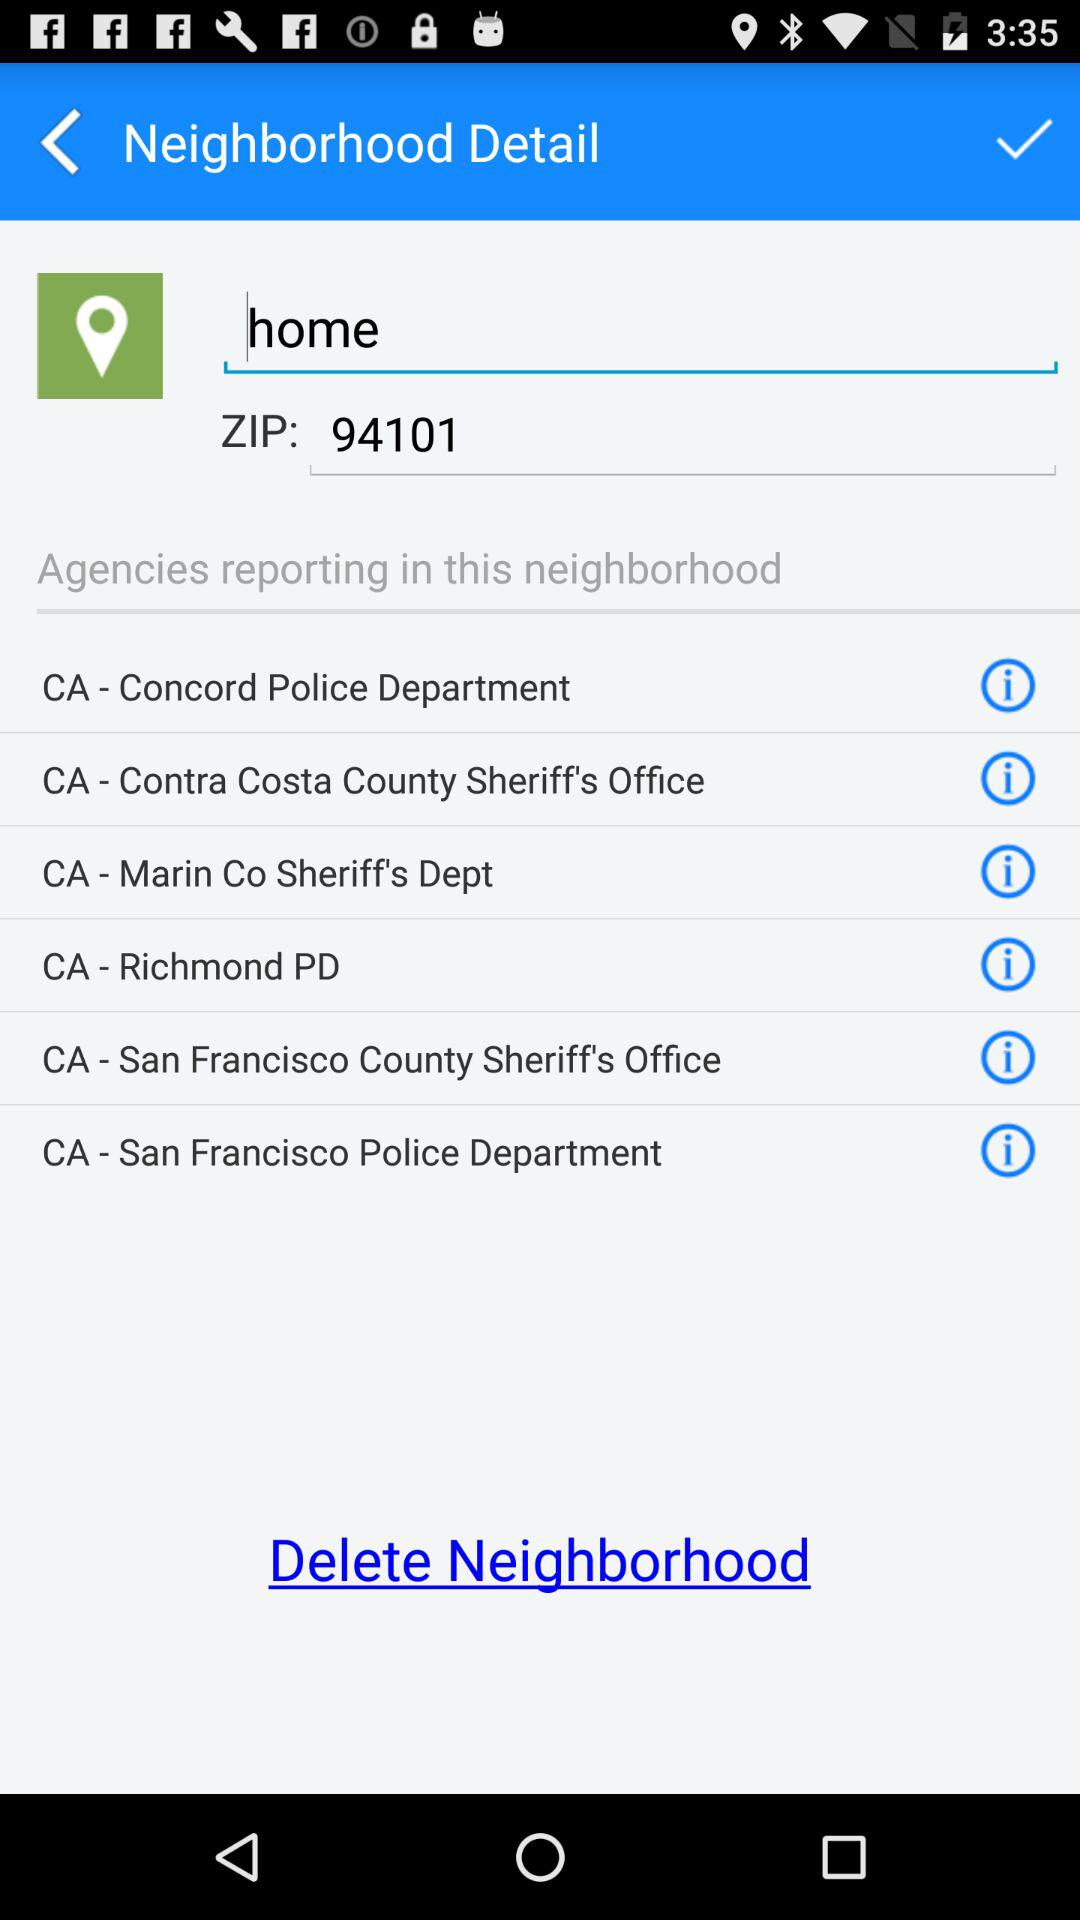What is the status of the neighborhood detail?
When the provided information is insufficient, respond with <no answer>. <no answer> 